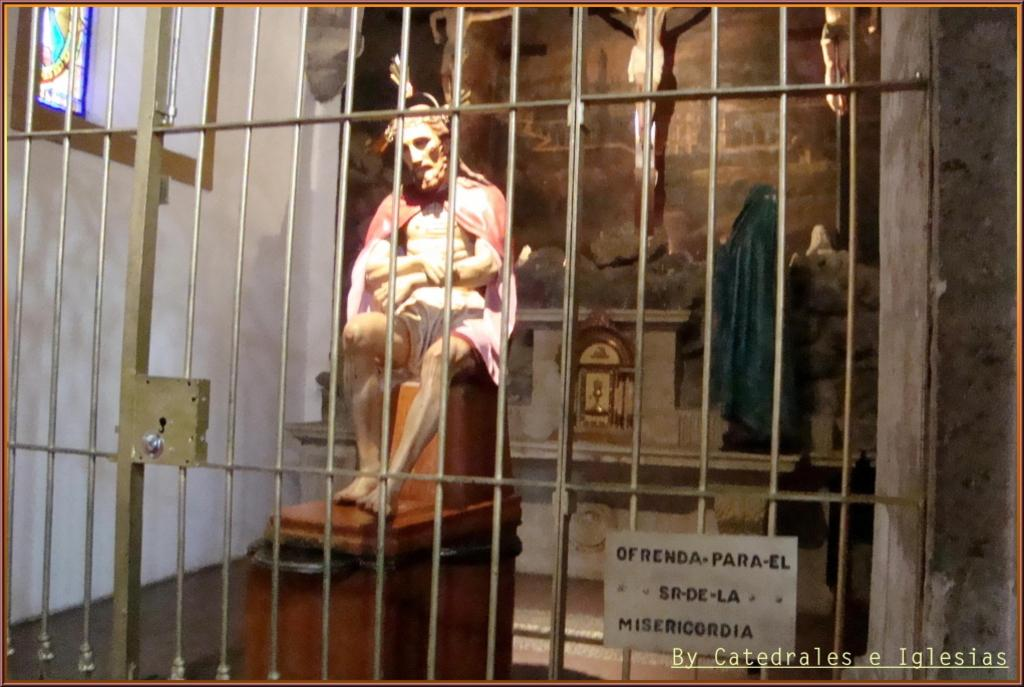What type of artwork is depicted in the image? There are sculptures in the image. Can you identify any specific sculpture in the image? One of the sculptures is Jesus. What is the purpose of the frame in the image? The frame is likely used to display or protect the sculptures. Is there a fight happening between the sculptures in the image? No, there is no fight depicted in the image; it features sculptures, including one of Jesus, and a frame. 